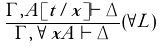Convert formula to latex. <formula><loc_0><loc_0><loc_500><loc_500>\frac { \Gamma , A [ t / x ] \vdash \Delta } { \Gamma , \forall x A \vdash \Delta } ( \forall L )</formula> 